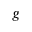<formula> <loc_0><loc_0><loc_500><loc_500>g</formula> 